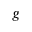<formula> <loc_0><loc_0><loc_500><loc_500>g</formula> 